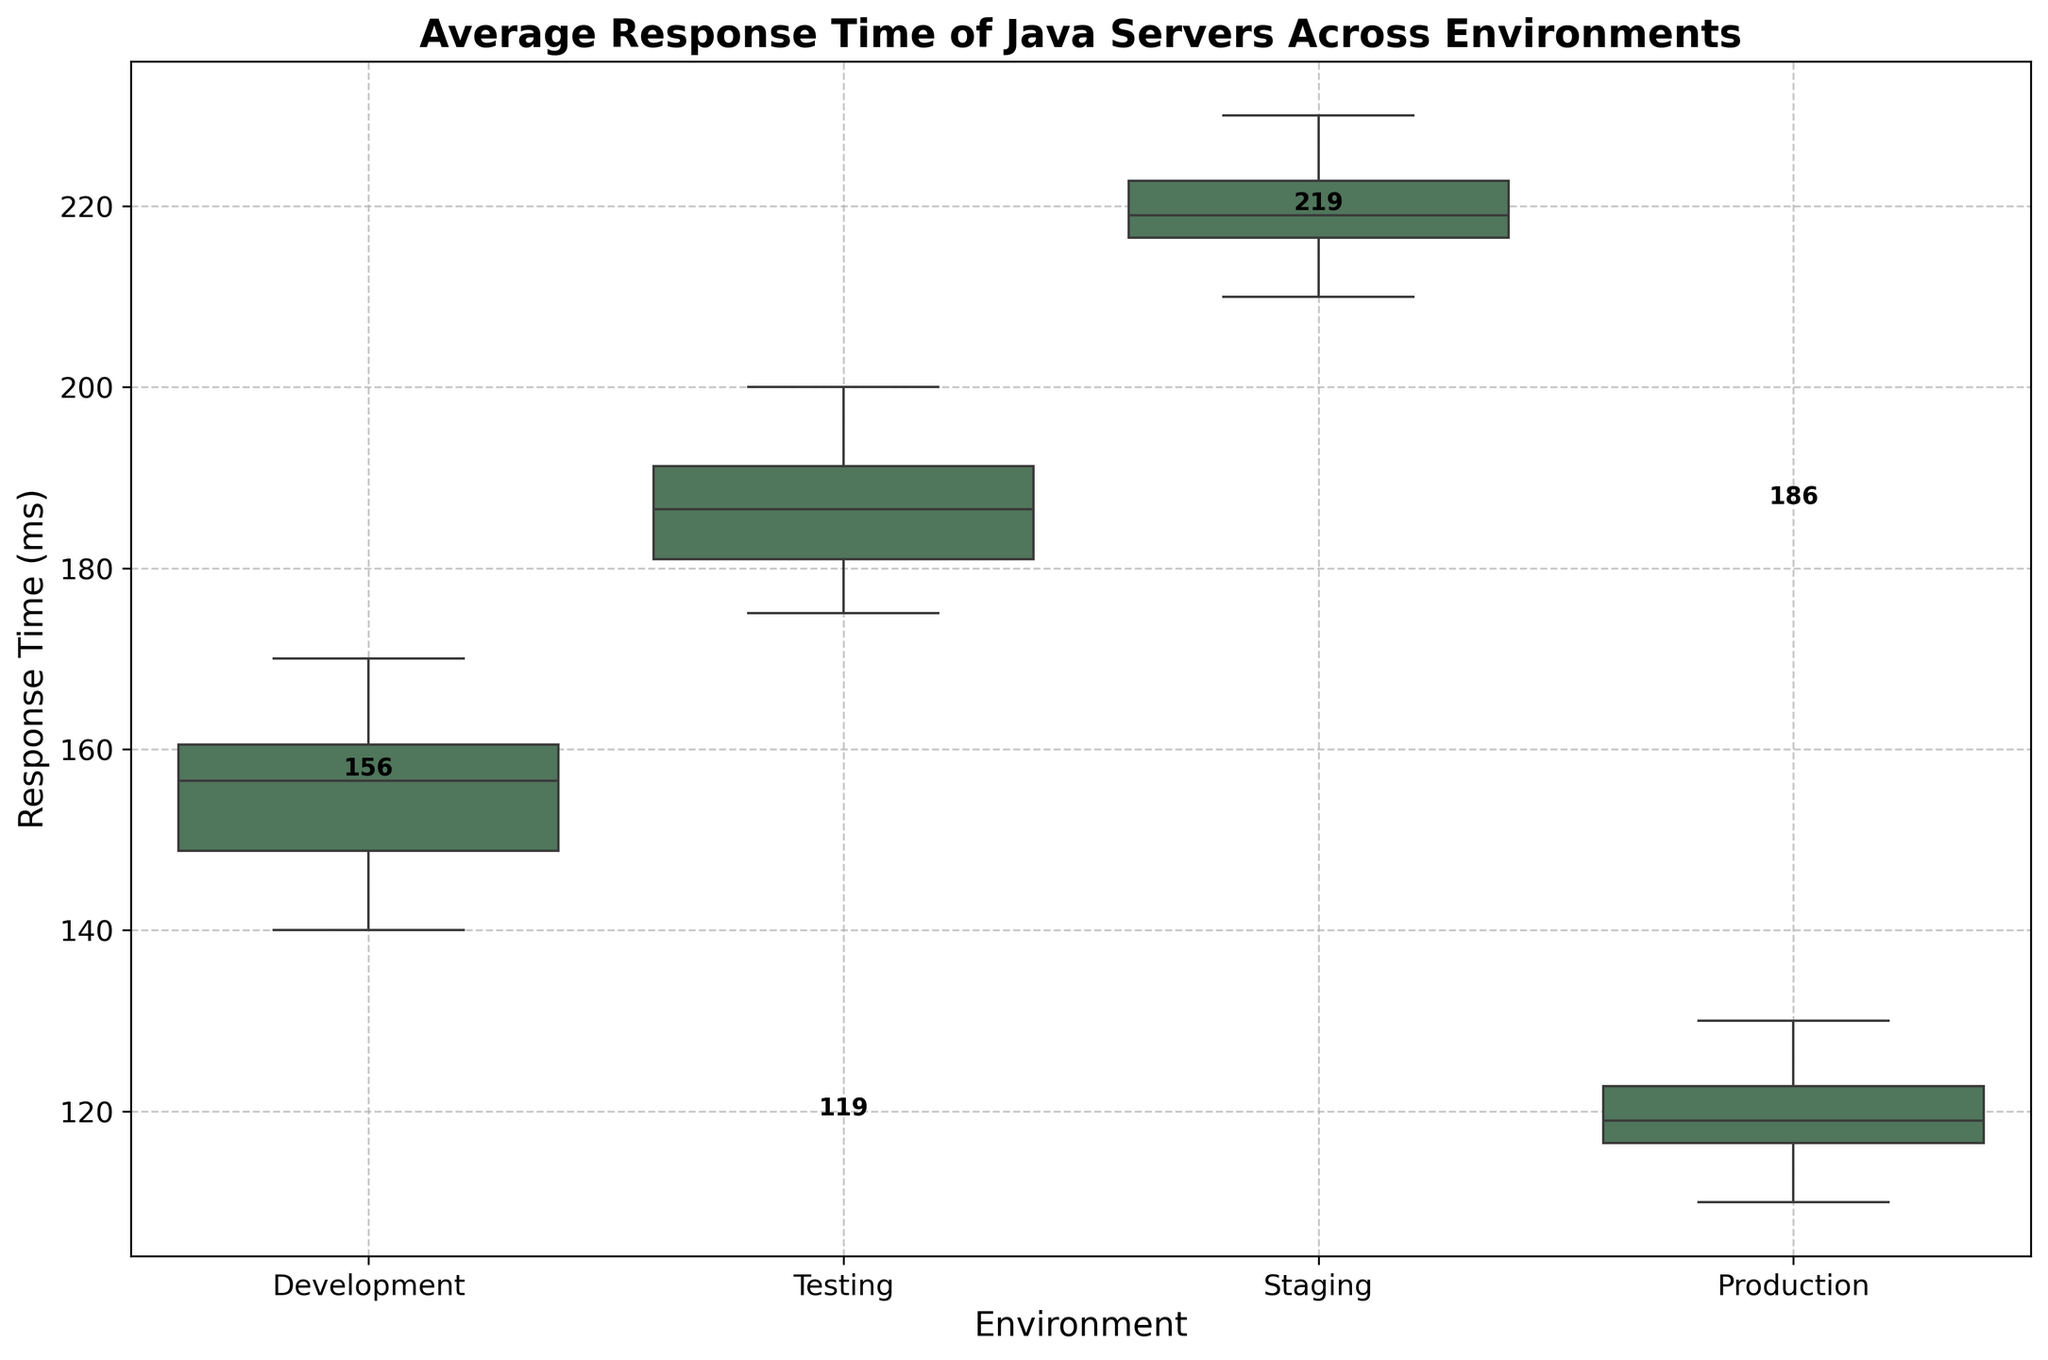What's the title of the plot? The title is usually displayed at the top of the plot, indicating the main subject or information being visualized. In this case, the title is "Average Response Time of Java Servers Across Environments".
Answer: Average Response Time of Java Servers Across Environments Which environment has the highest median response time? To determine this, look at the bold values marked on the box plots. The highest median value is the one that is the highest position on the vertical axis.
Answer: Staging What is the median response time for the Testing environment? The median value is usually marked within the box or mentioned explicitly. For the Testing environment, find the labeled median value in the plot.
Answer: 190 ms How does the median response time of Production compare to that of Development? Compare the bold median values for Production and Development. Determine which is higher or lower.
Answer: The median response time of Production is lower than that of Development What can you say about the spread of response times in the Staging environment compared to the Development environment? The spread or variability of the response times can be observed by looking at the length of the boxes and whiskers. Longer boxes and whiskers indicate greater variability.
Answer: The spread of response times in Staging is larger than in Development Which environment has the lowest minimum response time? The minimum response time can be found at the bottom whisker of each environment box plot. Compare the positions of the lowest whiskers.
Answer: Production How does the interquartile range (IQR) of Testing compare to Production? The IQR is the range covered by the box (the middle 50% of the data). Compare the widths of the boxes for Testing and Production.
Answer: The IQR of Testing is larger than that of Production What is the response time range for the Development environment? The range is found by subtracting the minimum value (bottom whisker) from the maximum value (top whisker).
Answer: 140 ms to 170 ms Which environment has the most consistent response times? Consistency in response times is indicated by a smaller range and a shorter box plot. Short boxes and whiskers suggest less variability.
Answer: Production 